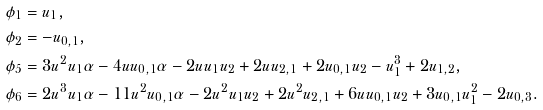<formula> <loc_0><loc_0><loc_500><loc_500>\phi _ { 1 } & = u _ { 1 } , \\ \phi _ { 2 } & = - u _ { 0 , 1 } , \\ \phi _ { 5 } & = 3 u ^ { 2 } u _ { 1 } \alpha - 4 u u _ { 0 , 1 } \alpha - 2 u u _ { 1 } u _ { 2 } + 2 u u _ { 2 , 1 } + 2 u _ { 0 , 1 } u _ { 2 } - u _ { 1 } ^ { 3 } + 2 u _ { 1 , 2 } , \\ \phi _ { 6 } & = 2 u ^ { 3 } u _ { 1 } \alpha - 1 1 u ^ { 2 } u _ { 0 , 1 } \alpha - 2 u ^ { 2 } u _ { 1 } u _ { 2 } + 2 u ^ { 2 } u _ { 2 , 1 } + 6 u u _ { 0 , 1 } u _ { 2 } + 3 u _ { 0 , 1 } u _ { 1 } ^ { 2 } - 2 u _ { 0 , 3 } .</formula> 